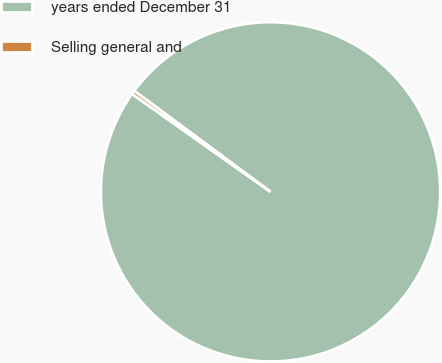<chart> <loc_0><loc_0><loc_500><loc_500><pie_chart><fcel>years ended December 31<fcel>Selling general and<nl><fcel>99.65%<fcel>0.35%<nl></chart> 